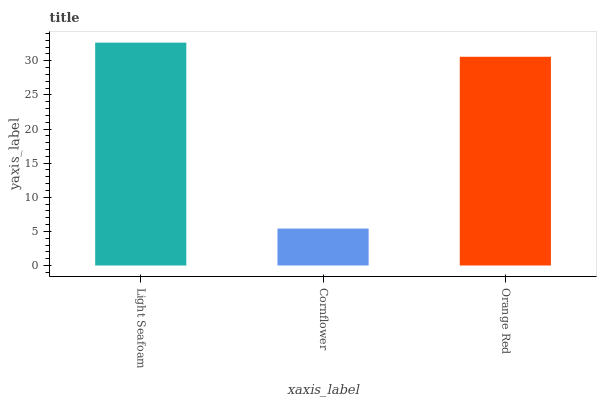Is Cornflower the minimum?
Answer yes or no. Yes. Is Light Seafoam the maximum?
Answer yes or no. Yes. Is Orange Red the minimum?
Answer yes or no. No. Is Orange Red the maximum?
Answer yes or no. No. Is Orange Red greater than Cornflower?
Answer yes or no. Yes. Is Cornflower less than Orange Red?
Answer yes or no. Yes. Is Cornflower greater than Orange Red?
Answer yes or no. No. Is Orange Red less than Cornflower?
Answer yes or no. No. Is Orange Red the high median?
Answer yes or no. Yes. Is Orange Red the low median?
Answer yes or no. Yes. Is Light Seafoam the high median?
Answer yes or no. No. Is Cornflower the low median?
Answer yes or no. No. 